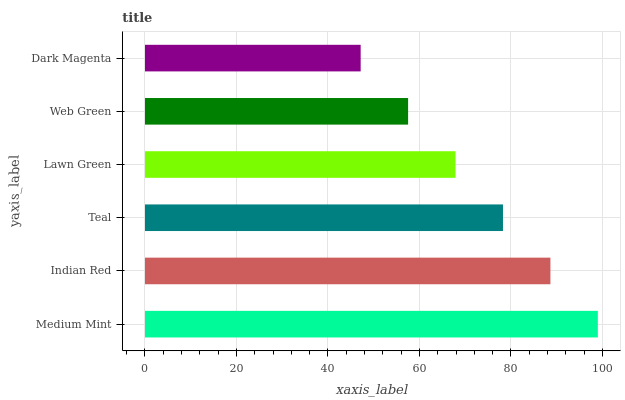Is Dark Magenta the minimum?
Answer yes or no. Yes. Is Medium Mint the maximum?
Answer yes or no. Yes. Is Indian Red the minimum?
Answer yes or no. No. Is Indian Red the maximum?
Answer yes or no. No. Is Medium Mint greater than Indian Red?
Answer yes or no. Yes. Is Indian Red less than Medium Mint?
Answer yes or no. Yes. Is Indian Red greater than Medium Mint?
Answer yes or no. No. Is Medium Mint less than Indian Red?
Answer yes or no. No. Is Teal the high median?
Answer yes or no. Yes. Is Lawn Green the low median?
Answer yes or no. Yes. Is Dark Magenta the high median?
Answer yes or no. No. Is Web Green the low median?
Answer yes or no. No. 